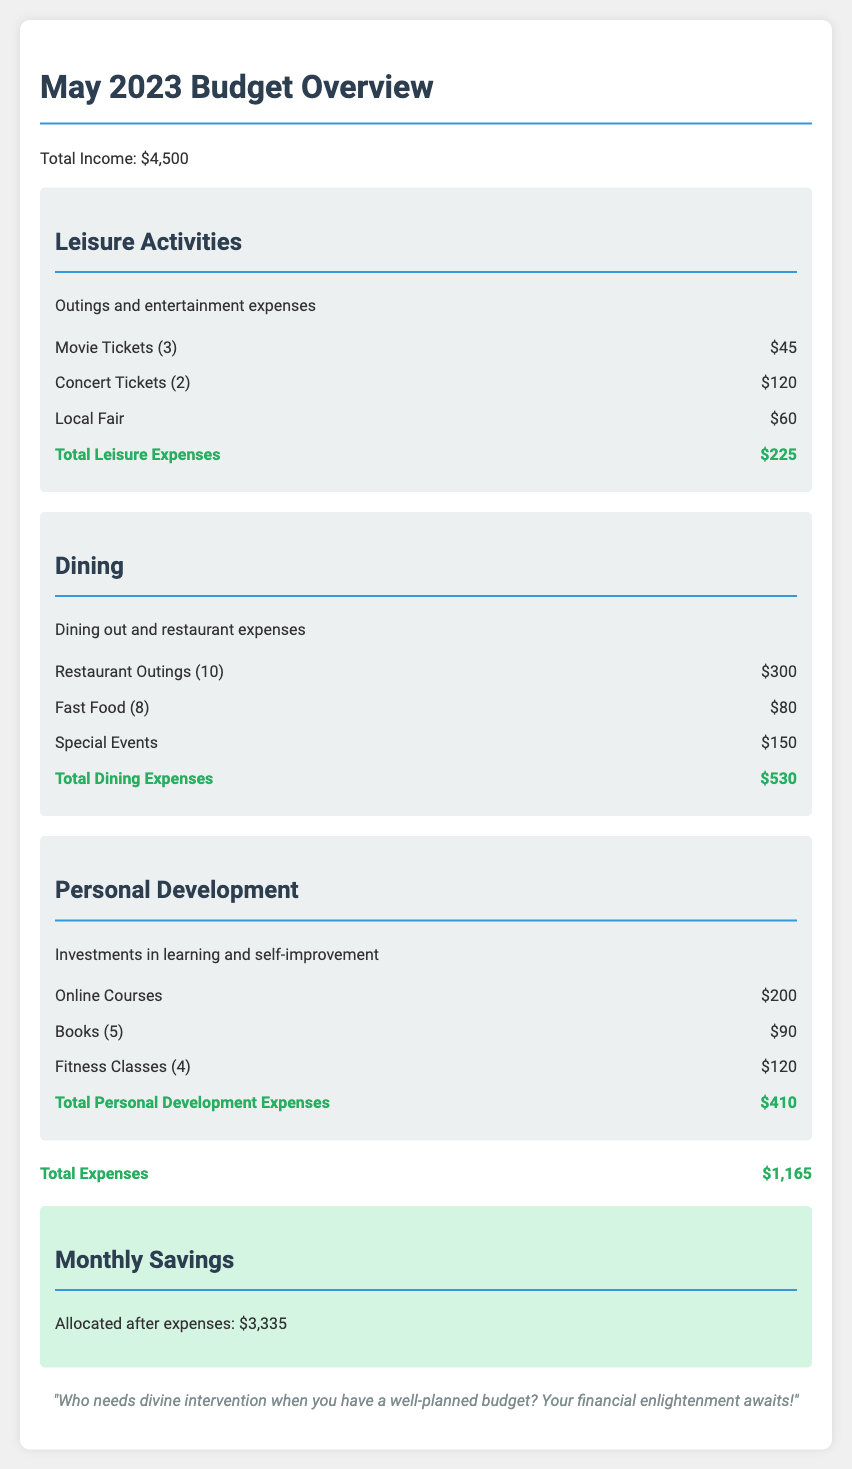What is the total income for May 2023? The total income is stated clearly in the document as $4,500.
Answer: $4,500 What are the total leisure expenses? The document provides a breakdown of leisure activities and their total, which is $225.
Answer: $225 How much was spent on dining? The dining section specifies the total spent on dining-related expenses as $530.
Answer: $530 What is the total for personal development expenses? The total personal development expenses are calculated in the document and listed as $410.
Answer: $410 What is the amount allocated for monthly savings? The document indicates the allocated savings after expenses as $3,335.
Answer: $3,335 How many concert tickets were purchased? The number of concert tickets listed in the leisure activities section is 2.
Answer: 2 What type of activities are included under personal development? The personal development category encompasses online courses, books, and fitness classes.
Answer: Online courses, books, fitness classes What was the most expensive dining expense in the document? The document mentions special events as the most expensive dining expense at $150.
Answer: Special Events How many restaurant outings were noted in the dining section? The document records that 10 restaurant outings took place, as stated.
Answer: 10 